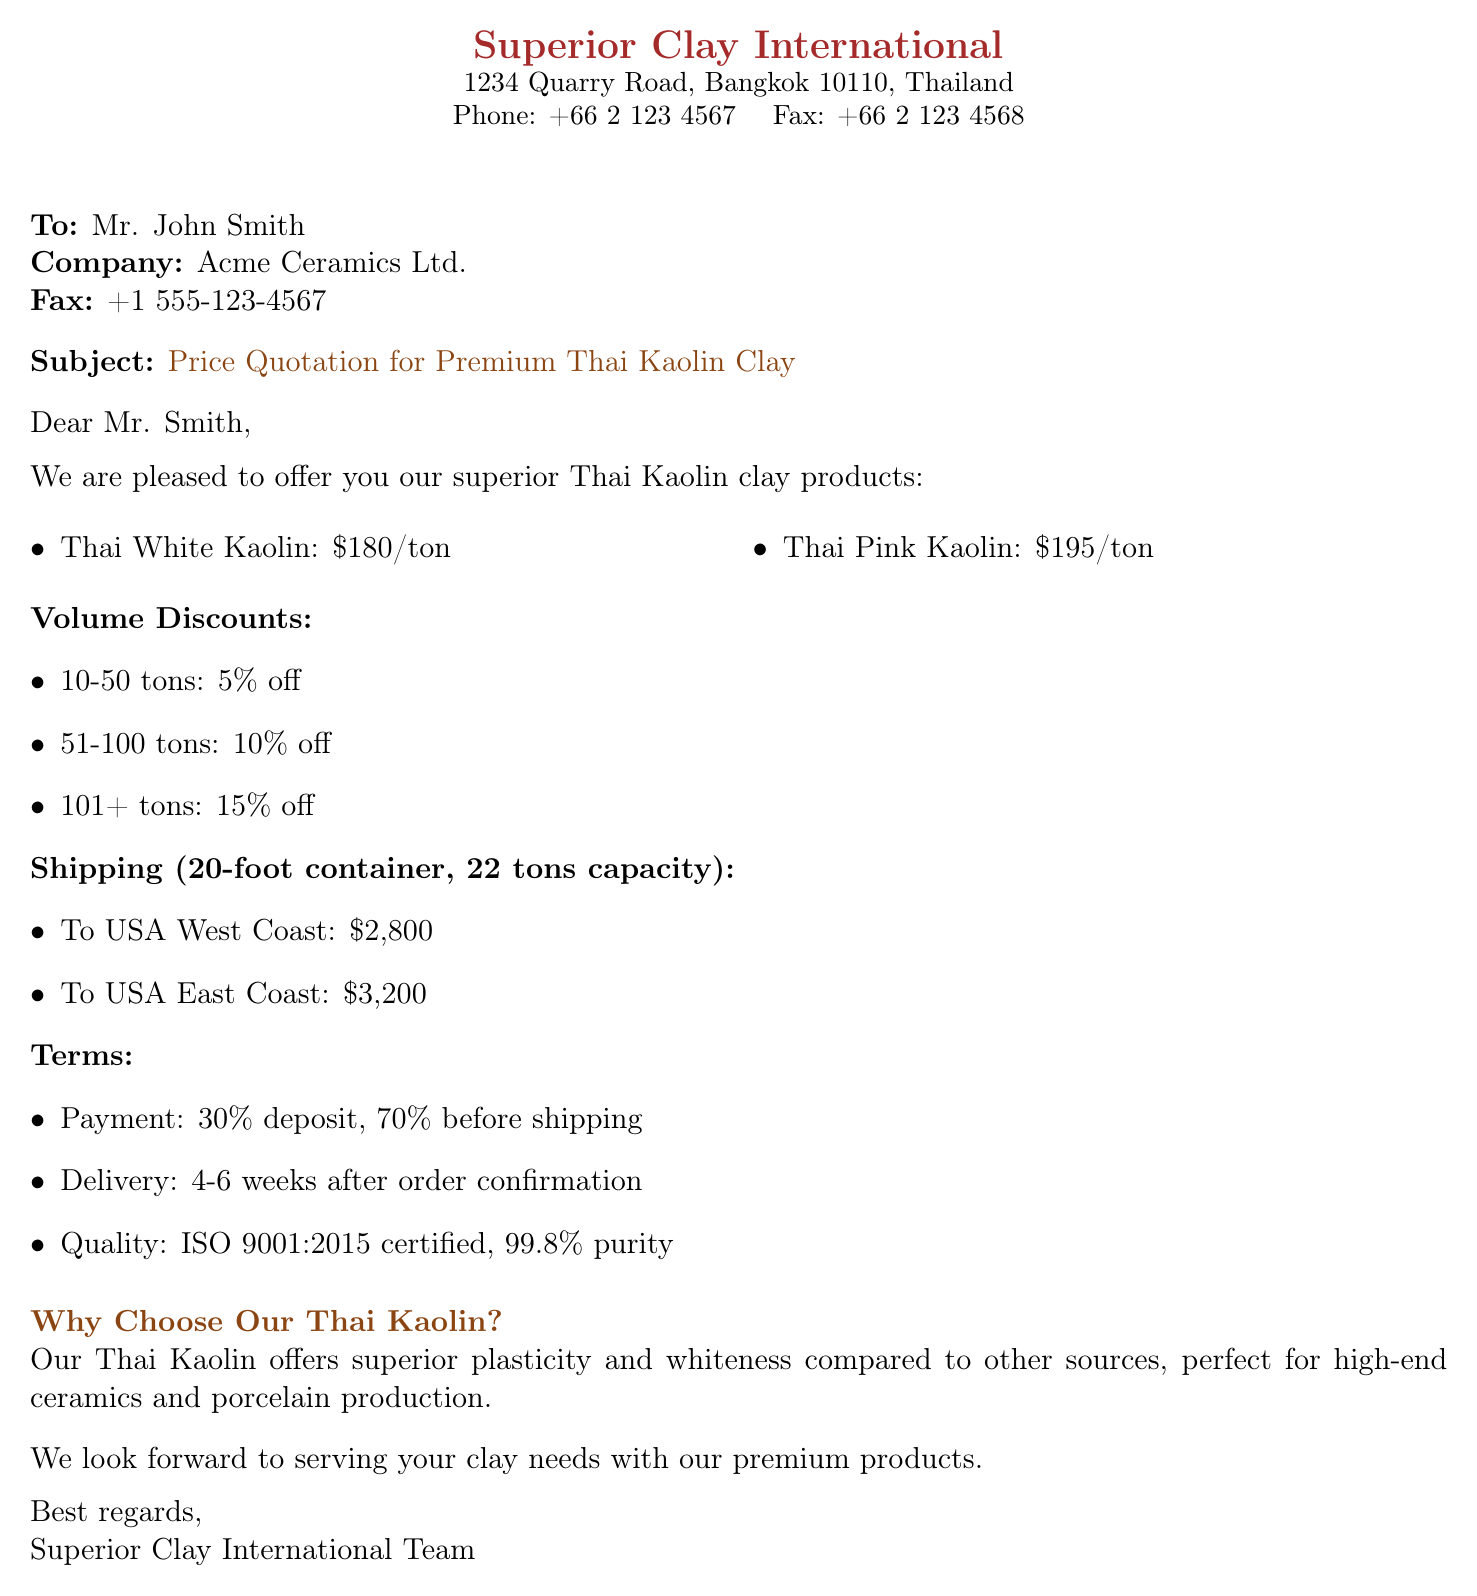What is the price of Thai White Kaolin? The document states the price for Thai White Kaolin is specified as $180/ton.
Answer: $180/ton What is the discount for ordering 60 tons? The document mentions a discount of 10% for orders between 51-100 tons.
Answer: 10% What are the shipping costs to the USA East Coast? The document provides the shipping cost to the USA East Coast as $3,200.
Answer: $3,200 What is the purity percentage of the clay? The document specifies that the purity of the clay is 99.8%.
Answer: 99.8% What is the payment structure mentioned in the document? The document outlines a payment structure of 30% deposit and 70% before shipping.
Answer: 30% deposit, 70% before shipping How long is the delivery time after order confirmation? The document indicates that the delivery time is 4-6 weeks after order confirmation.
Answer: 4-6 weeks Who is the recipient of this fax? The fax is addressed to Mr. John Smith.
Answer: Mr. John Smith What certification does the product have? The document states that the product is ISO 9001:2015 certified.
Answer: ISO 9001:2015 certified 